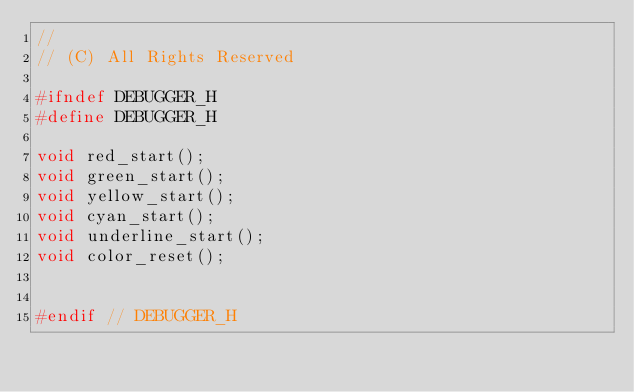<code> <loc_0><loc_0><loc_500><loc_500><_C_>//
// (C) All Rights Reserved

#ifndef DEBUGGER_H
#define DEBUGGER_H

void red_start();
void green_start();
void yellow_start();
void cyan_start();
void underline_start();
void color_reset();


#endif // DEBUGGER_H
</code> 